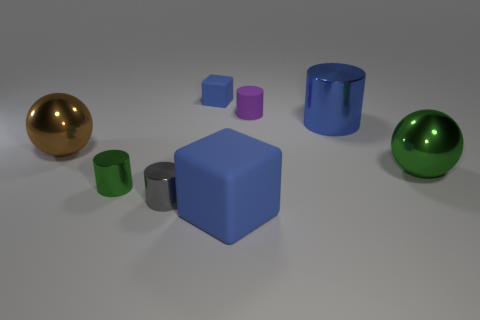Subtract 1 cylinders. How many cylinders are left? 3 Add 1 big brown metallic things. How many objects exist? 9 Subtract all yellow cylinders. Subtract all brown cubes. How many cylinders are left? 4 Subtract all balls. How many objects are left? 6 Subtract all small gray metallic cylinders. Subtract all cylinders. How many objects are left? 3 Add 1 green cylinders. How many green cylinders are left? 2 Add 1 large green balls. How many large green balls exist? 2 Subtract 0 cyan cylinders. How many objects are left? 8 